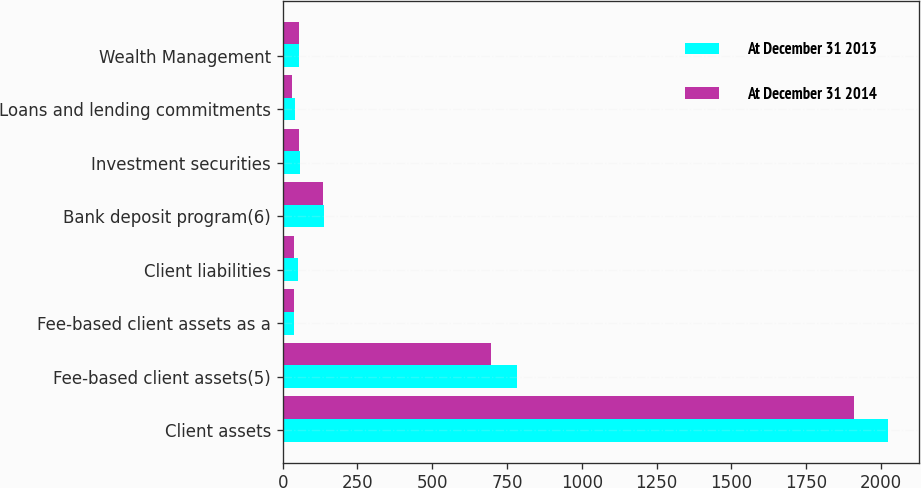Convert chart. <chart><loc_0><loc_0><loc_500><loc_500><stacked_bar_chart><ecel><fcel>Client assets<fcel>Fee-based client assets(5)<fcel>Fee-based client assets as a<fcel>Client liabilities<fcel>Bank deposit program(6)<fcel>Investment securities<fcel>Loans and lending commitments<fcel>Wealth Management<nl><fcel>At December 31 2013<fcel>2025<fcel>785<fcel>39<fcel>51<fcel>137<fcel>57.3<fcel>42.7<fcel>55.35<nl><fcel>At December 31 2014<fcel>1909<fcel>697<fcel>37<fcel>39<fcel>134<fcel>53.4<fcel>29.5<fcel>55.35<nl></chart> 